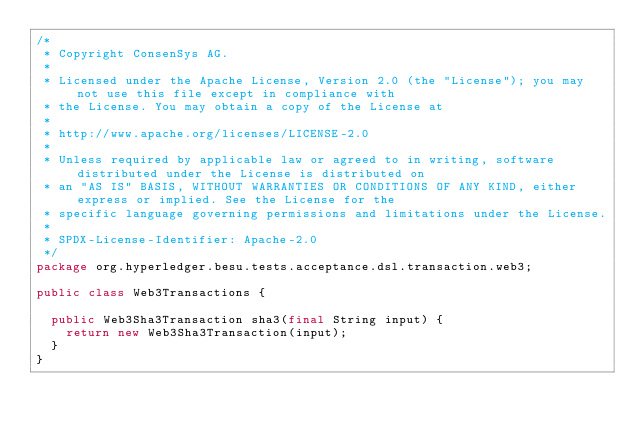<code> <loc_0><loc_0><loc_500><loc_500><_Java_>/*
 * Copyright ConsenSys AG.
 *
 * Licensed under the Apache License, Version 2.0 (the "License"); you may not use this file except in compliance with
 * the License. You may obtain a copy of the License at
 *
 * http://www.apache.org/licenses/LICENSE-2.0
 *
 * Unless required by applicable law or agreed to in writing, software distributed under the License is distributed on
 * an "AS IS" BASIS, WITHOUT WARRANTIES OR CONDITIONS OF ANY KIND, either express or implied. See the License for the
 * specific language governing permissions and limitations under the License.
 *
 * SPDX-License-Identifier: Apache-2.0
 */
package org.hyperledger.besu.tests.acceptance.dsl.transaction.web3;

public class Web3Transactions {

  public Web3Sha3Transaction sha3(final String input) {
    return new Web3Sha3Transaction(input);
  }
}
</code> 